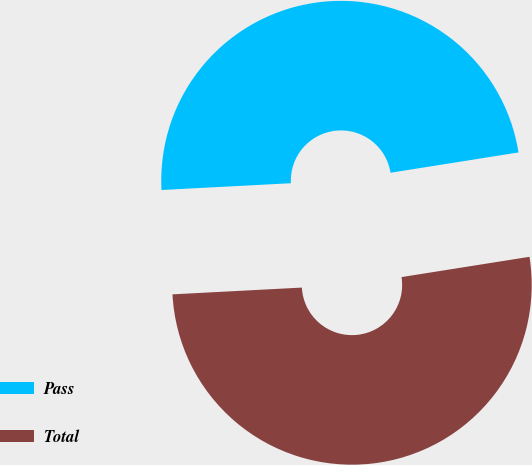Convert chart to OTSL. <chart><loc_0><loc_0><loc_500><loc_500><pie_chart><fcel>Pass<fcel>Total<nl><fcel>48.33%<fcel>51.67%<nl></chart> 